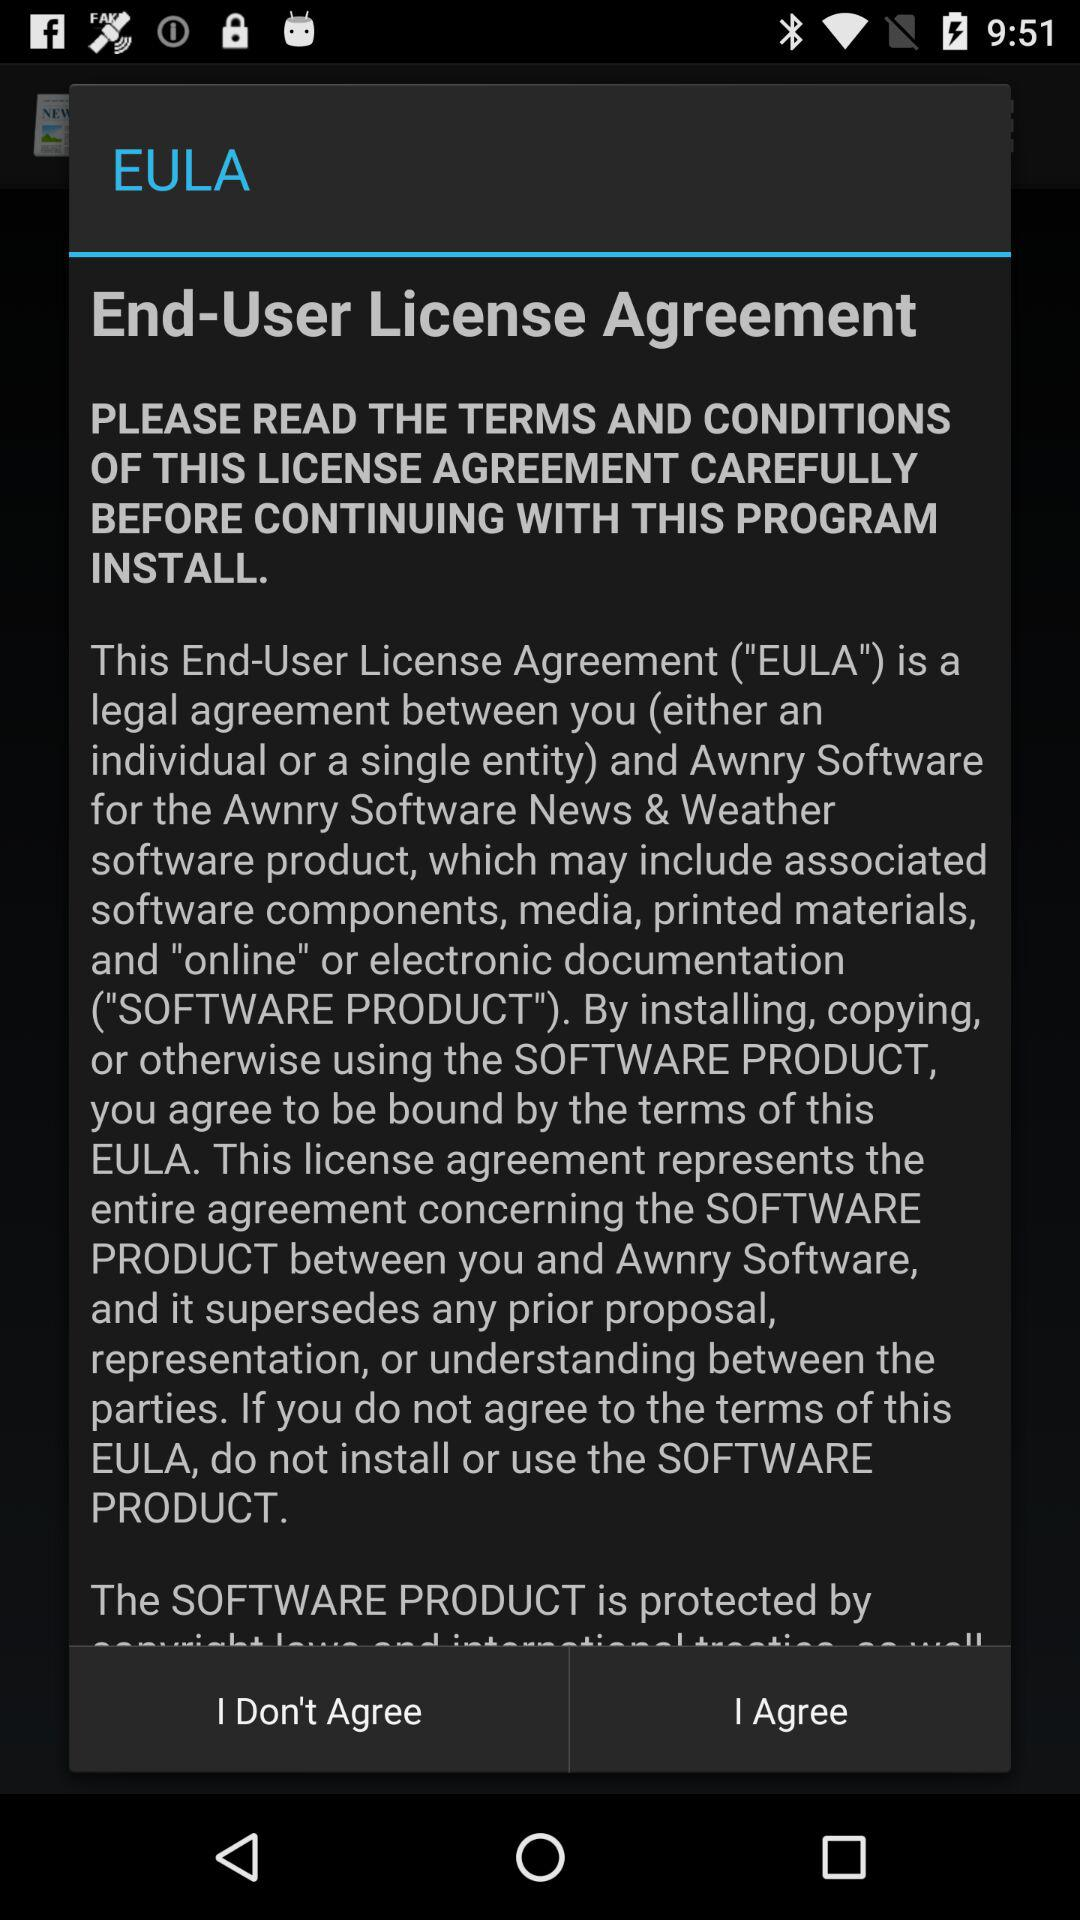Which option is selected?
When the provided information is insufficient, respond with <no answer>. <no answer> 